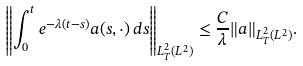Convert formula to latex. <formula><loc_0><loc_0><loc_500><loc_500>\left \| \int _ { 0 } ^ { t } e ^ { - \lambda ( t - s ) } a ( s , \cdot ) \, d s \right \| _ { L ^ { 2 } _ { T } ( L ^ { 2 } ) } \leq \frac { C } { \lambda } \| a \| _ { L ^ { 2 } _ { T } ( L ^ { 2 } ) } .</formula> 